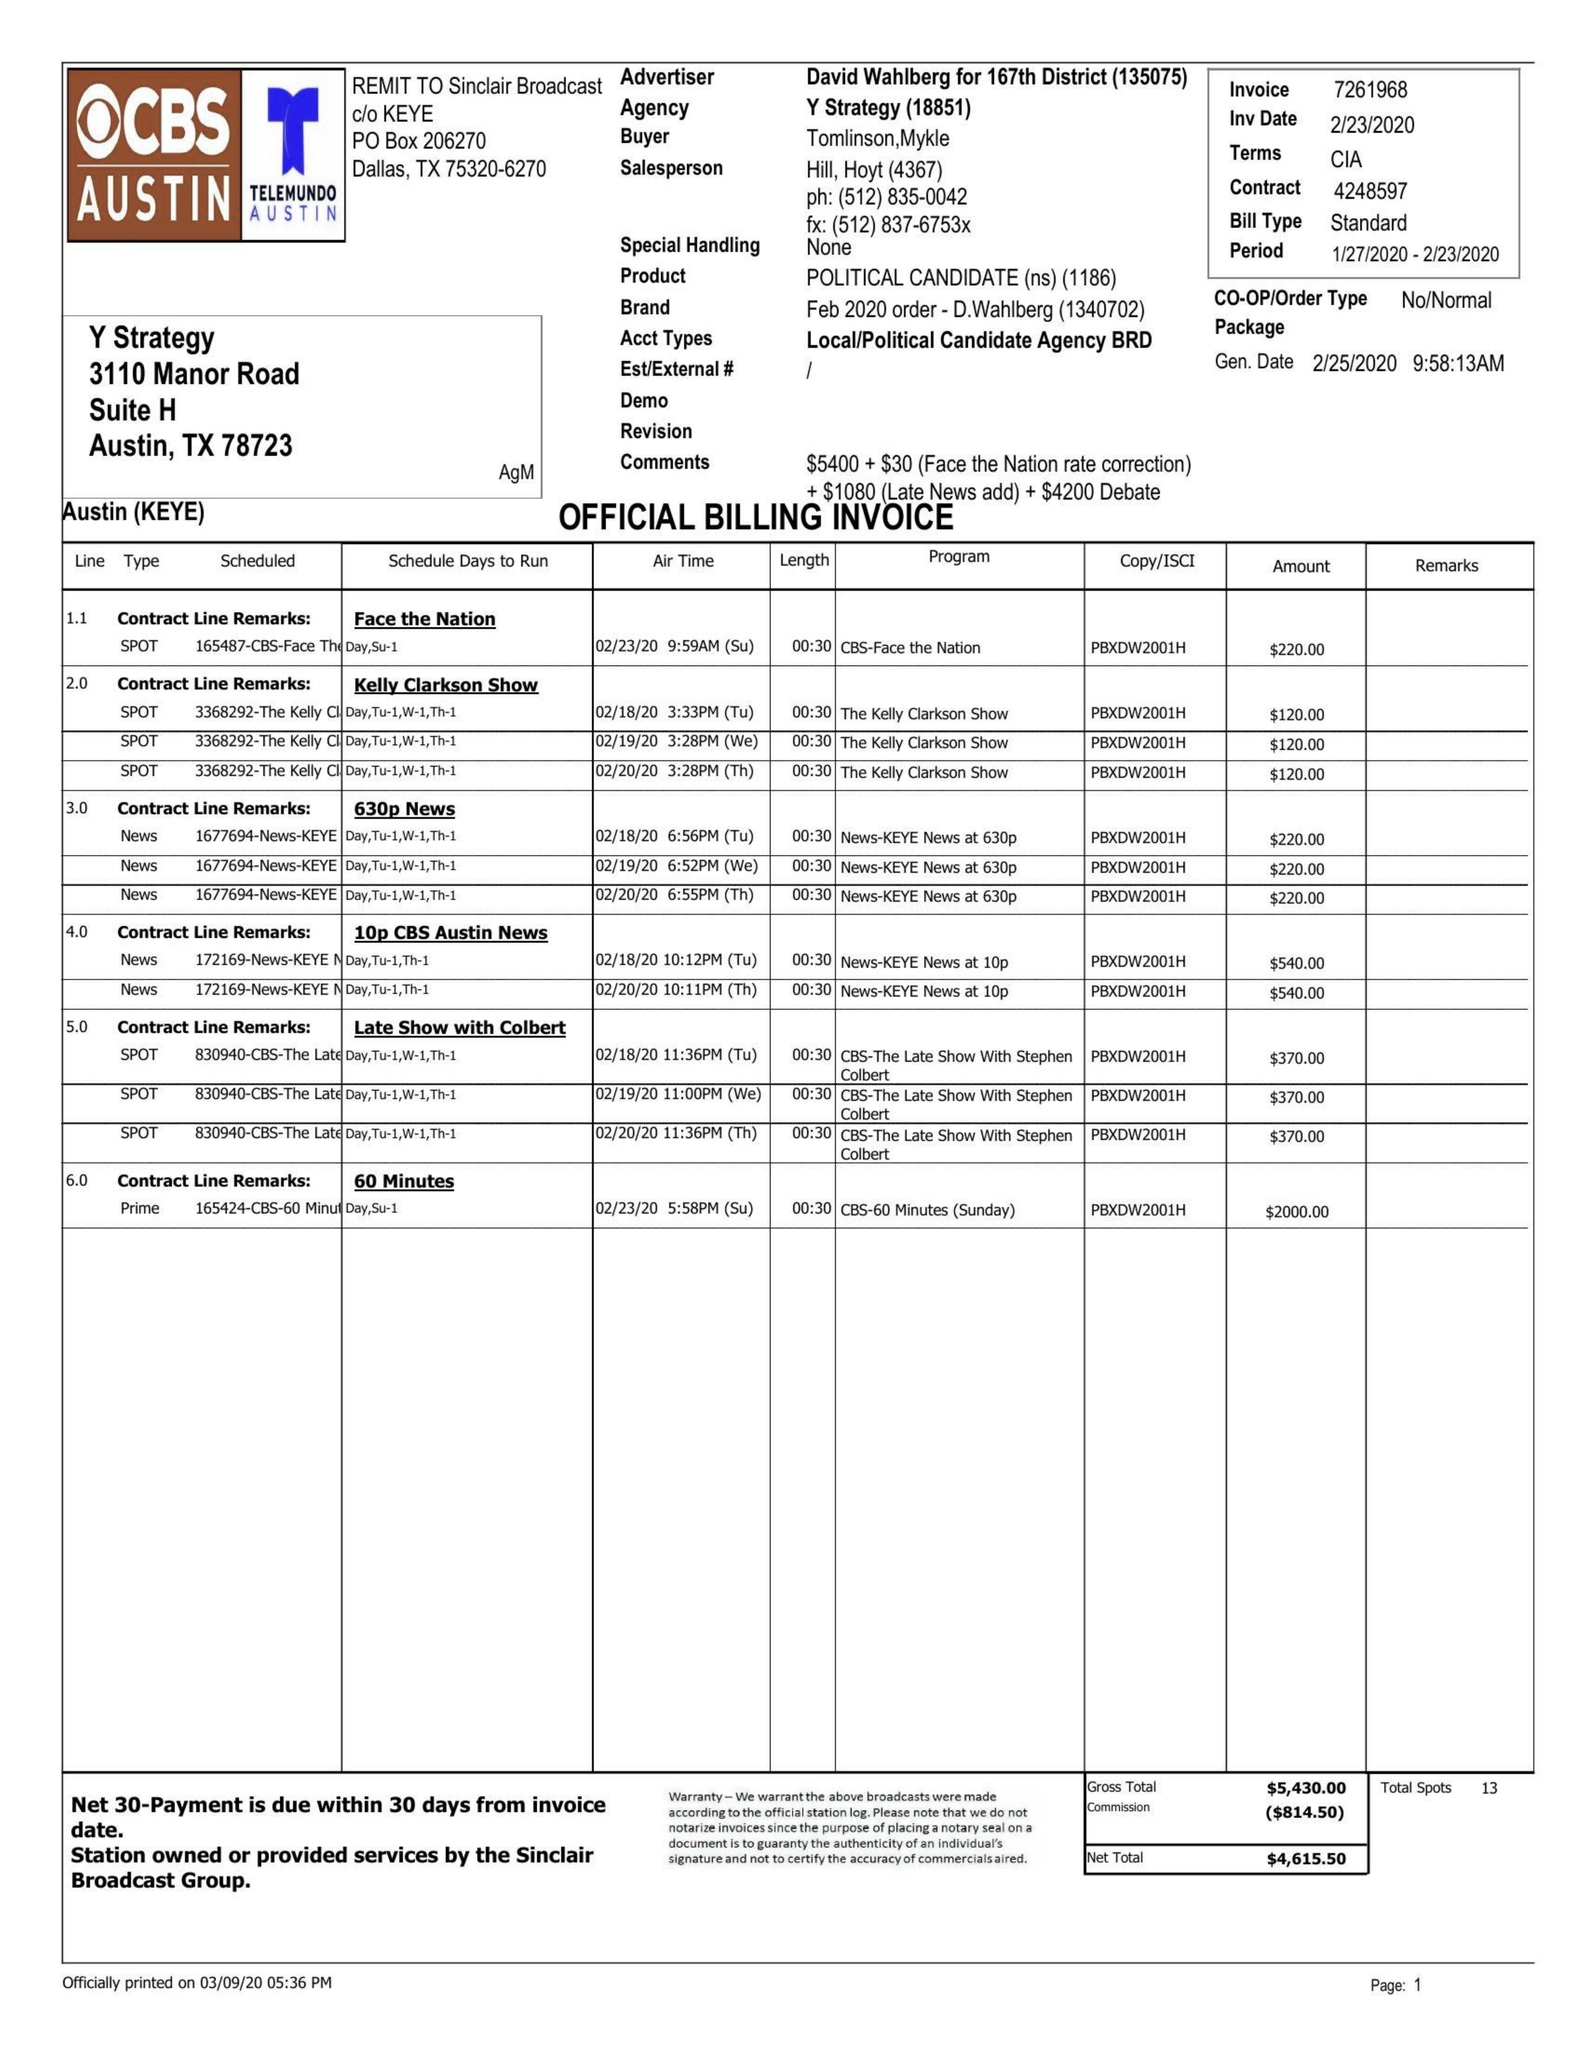What is the value for the flight_to?
Answer the question using a single word or phrase. 02/23/20 